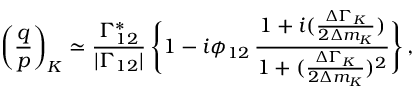Convert formula to latex. <formula><loc_0><loc_0><loc_500><loc_500>\left ( { \frac { q } { p } } \right ) _ { K } \simeq { \frac { \Gamma _ { 1 2 } ^ { * } } { | \Gamma _ { 1 2 } | } } \, \left \{ 1 - i \phi _ { 1 2 } \, { \frac { 1 + i ( { \frac { \Delta \Gamma _ { K } } { 2 \Delta m _ { K } } } ) } { 1 + ( { \frac { \Delta \Gamma _ { K } } { 2 \Delta m _ { K } } } ) ^ { 2 } } } \right \} \, ,</formula> 